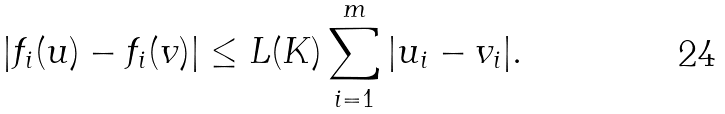Convert formula to latex. <formula><loc_0><loc_0><loc_500><loc_500>| f _ { i } ( u ) - f _ { i } ( v ) | \leq L ( K ) \sum _ { i = 1 } ^ { m } | u _ { i } - v _ { i } | .</formula> 